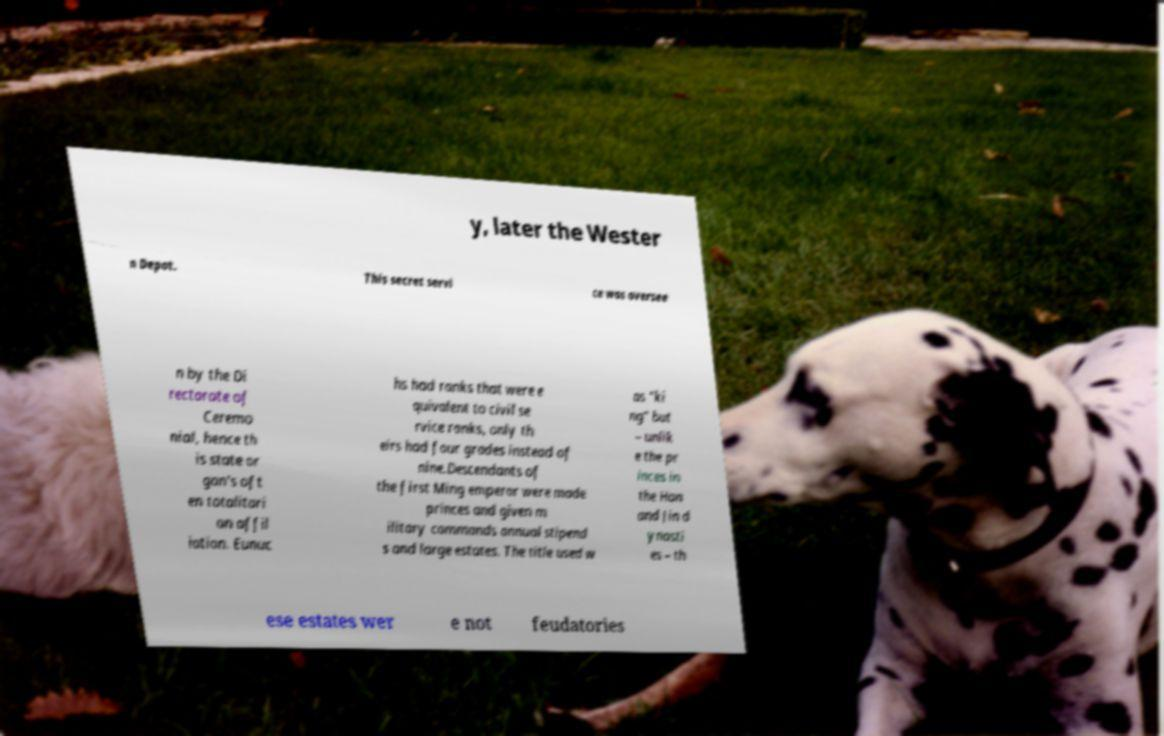Please identify and transcribe the text found in this image. y, later the Wester n Depot. This secret servi ce was oversee n by the Di rectorate of Ceremo nial, hence th is state or gan's oft en totalitari an affil iation. Eunuc hs had ranks that were e quivalent to civil se rvice ranks, only th eirs had four grades instead of nine.Descendants of the first Ming emperor were made princes and given m ilitary commands annual stipend s and large estates. The title used w as "ki ng" but – unlik e the pr inces in the Han and Jin d ynasti es – th ese estates wer e not feudatories 